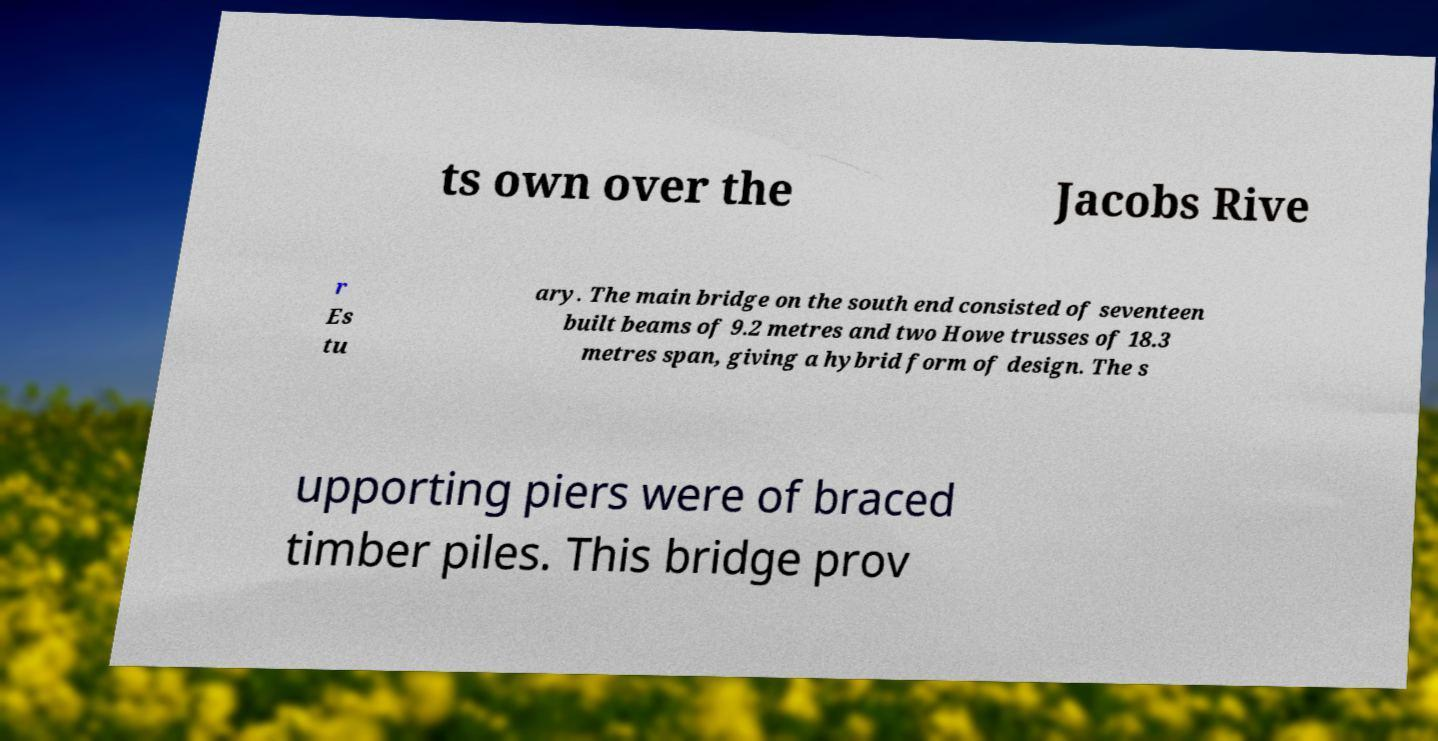Please identify and transcribe the text found in this image. ts own over the Jacobs Rive r Es tu ary. The main bridge on the south end consisted of seventeen built beams of 9.2 metres and two Howe trusses of 18.3 metres span, giving a hybrid form of design. The s upporting piers were of braced timber piles. This bridge prov 